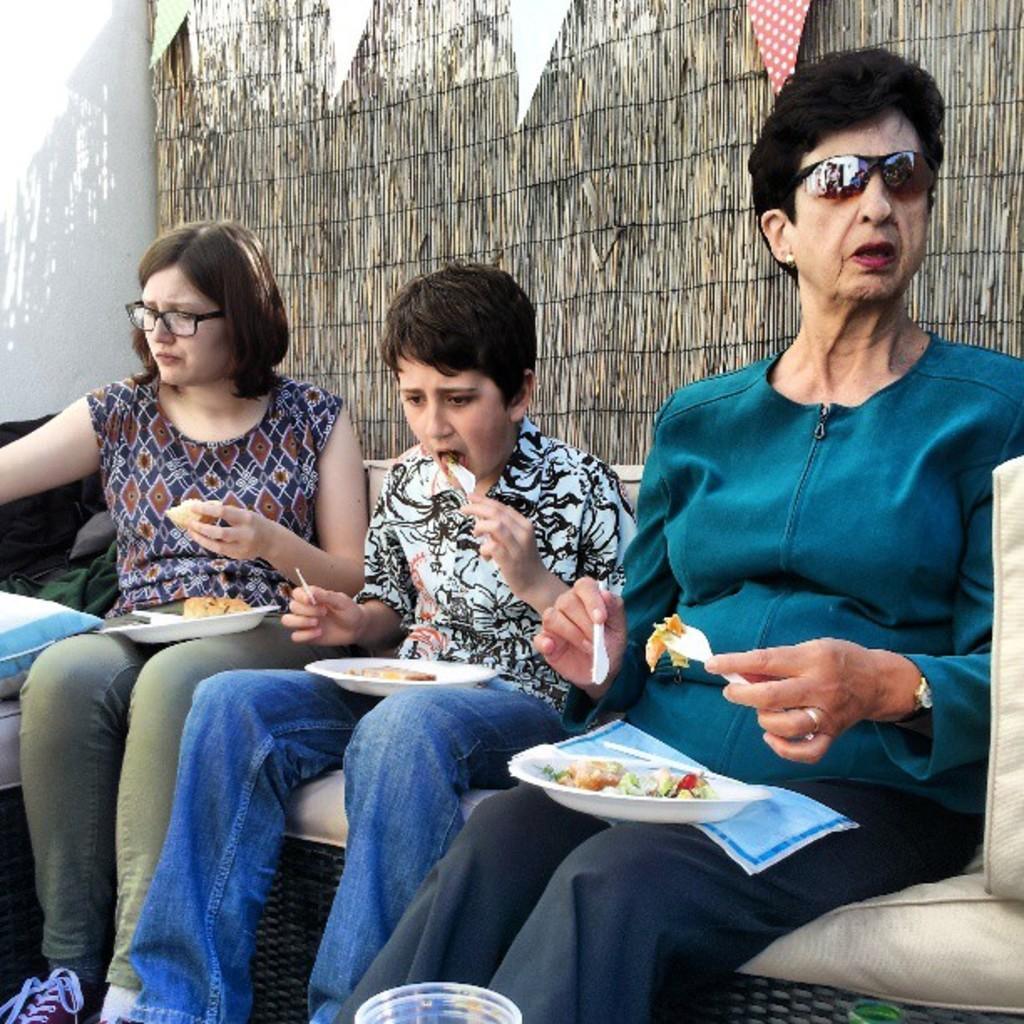In one or two sentences, can you explain what this image depicts? In this picture, we see two women and a boy are sitting on the sofa. We see the plates containing the food are placed on their laps. They are eating the food. The woman on the right side is holding a fork and a knife in her hands. At the bottom, we see the glasses. On the left side, we see a pillow. In the left top, we see a wall in white color. In the background, we see a wooden blind and the flags in white, red and green color. 